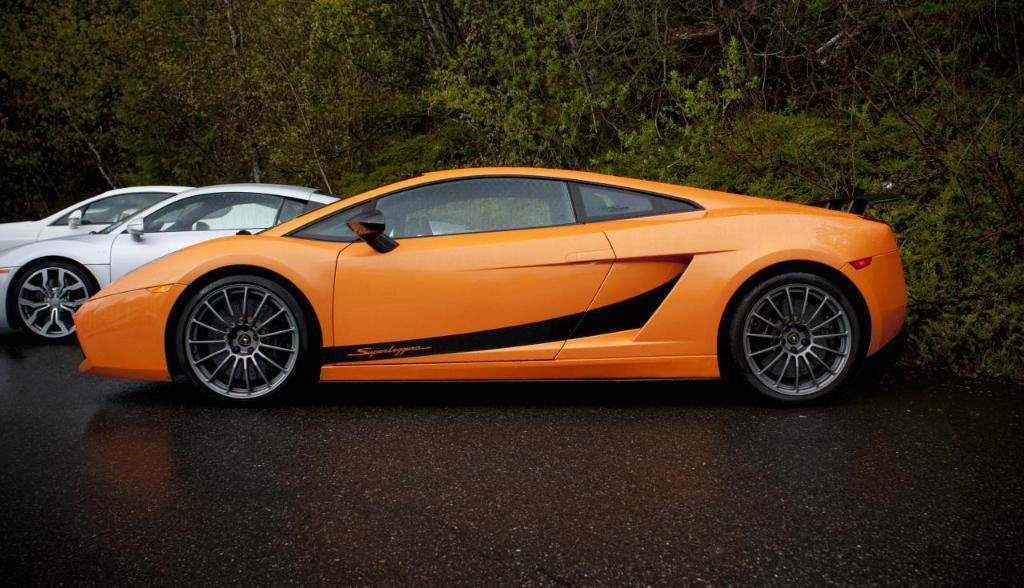Can you describe this image briefly? In the center of the image there are cars on the road. In the background of the image there are trees. 